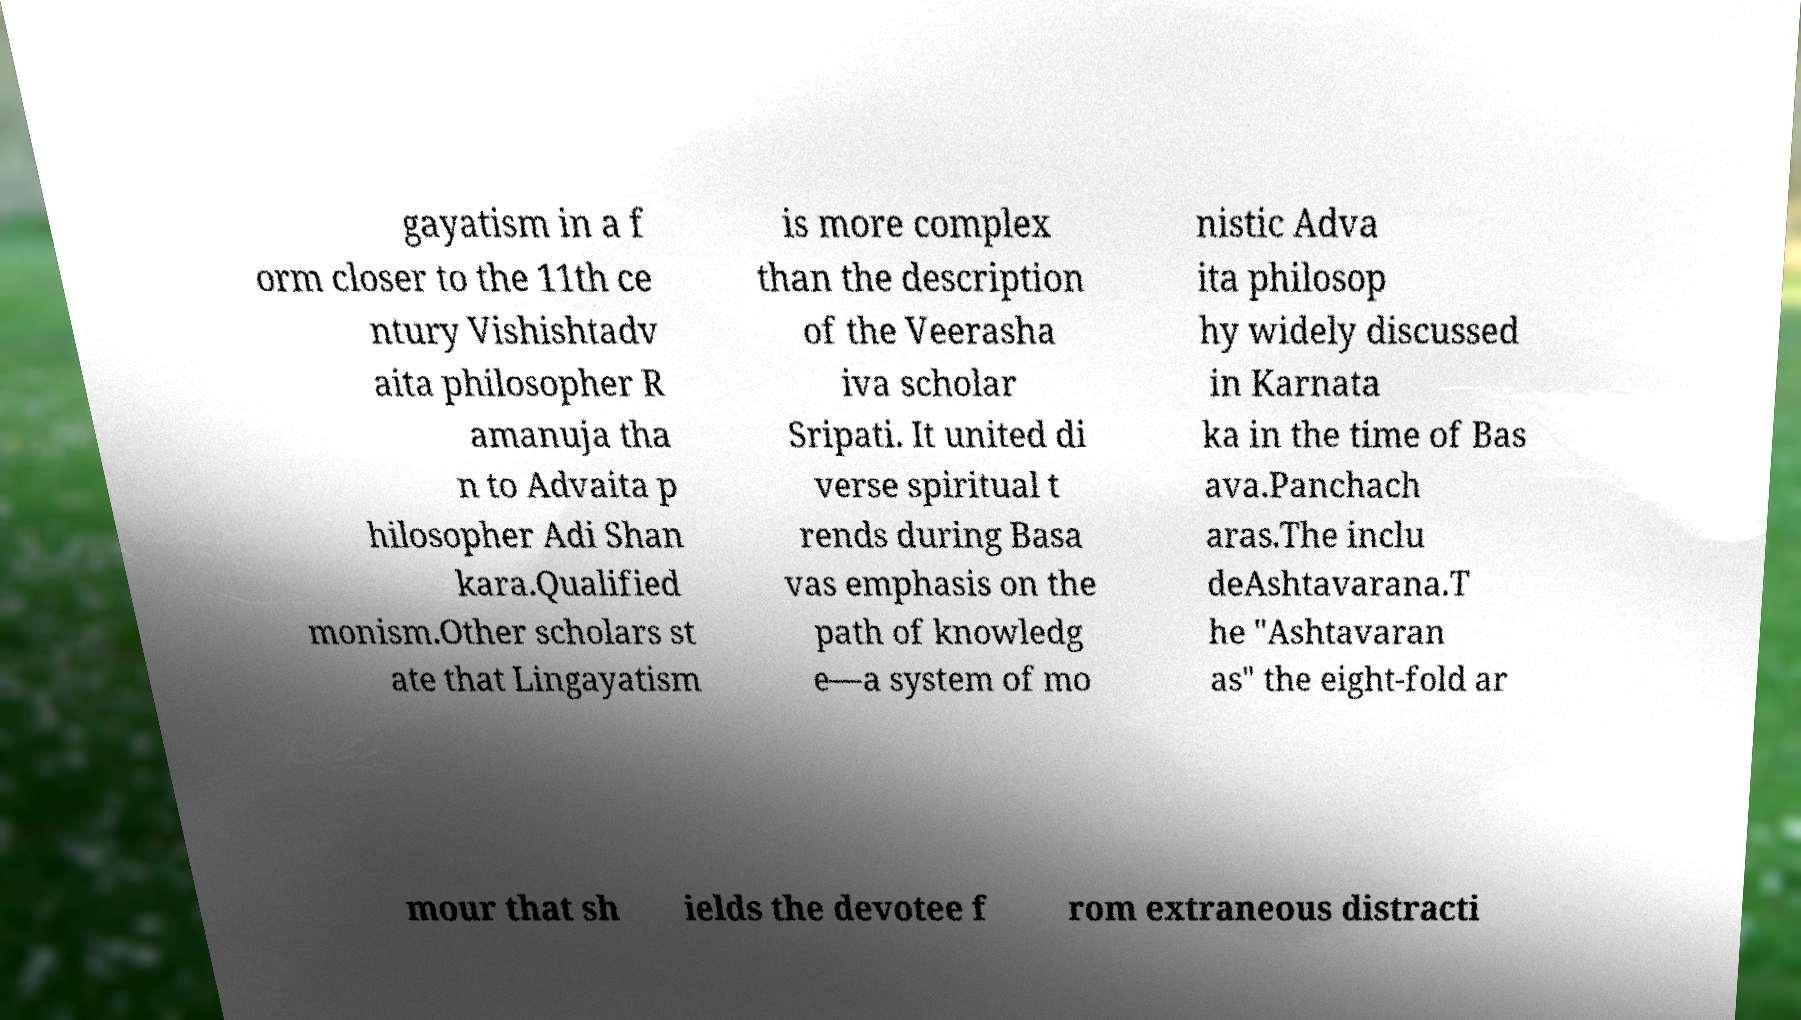What messages or text are displayed in this image? I need them in a readable, typed format. gayatism in a f orm closer to the 11th ce ntury Vishishtadv aita philosopher R amanuja tha n to Advaita p hilosopher Adi Shan kara.Qualified monism.Other scholars st ate that Lingayatism is more complex than the description of the Veerasha iva scholar Sripati. It united di verse spiritual t rends during Basa vas emphasis on the path of knowledg e—a system of mo nistic Adva ita philosop hy widely discussed in Karnata ka in the time of Bas ava.Panchach aras.The inclu deAshtavarana.T he "Ashtavaran as" the eight-fold ar mour that sh ields the devotee f rom extraneous distracti 